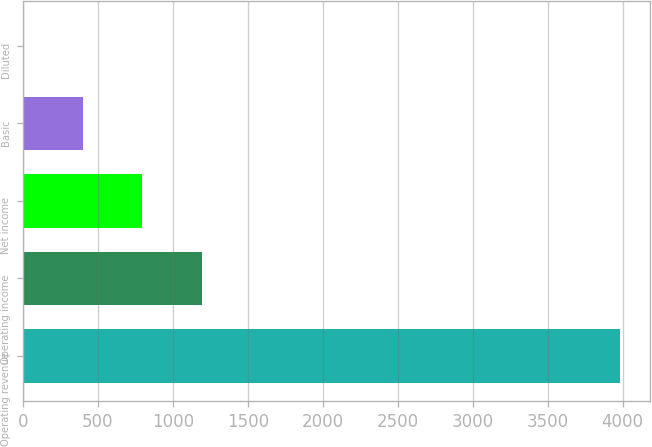Convert chart. <chart><loc_0><loc_0><loc_500><loc_500><bar_chart><fcel>Operating revenue<fcel>Operating income<fcel>Net income<fcel>Basic<fcel>Diluted<nl><fcel>3983<fcel>1195.99<fcel>797.84<fcel>399.69<fcel>1.54<nl></chart> 